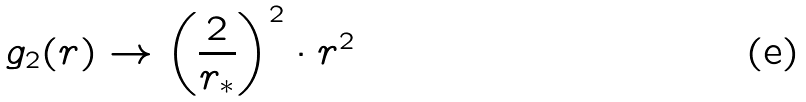Convert formula to latex. <formula><loc_0><loc_0><loc_500><loc_500>g _ { 2 } ( r ) \to \left ( \frac { 2 } { r _ { * } } \right ) ^ { 2 } \cdot r ^ { 2 }</formula> 